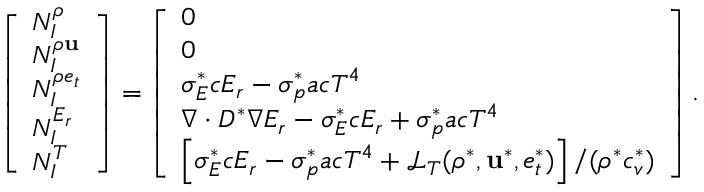Convert formula to latex. <formula><loc_0><loc_0><loc_500><loc_500>\left [ \begin{array} { l } { N _ { I } ^ { \rho } } \\ { N _ { I } ^ { \rho u } } \\ { N _ { I } ^ { \rho e _ { t } } } \\ { N _ { I } ^ { E _ { r } } } \\ { N _ { I } ^ { T } } \end{array} \right ] = \left [ \begin{array} { l } { 0 } \\ { 0 } \\ { \sigma _ { E } ^ { * } c E _ { r } - \sigma _ { p } ^ { * } a c T ^ { 4 } } \\ { \nabla \cdot D ^ { * } \nabla E _ { r } - \sigma _ { E } ^ { * } c E _ { r } + \sigma _ { p } ^ { * } a c T ^ { 4 } } \\ { \left [ \sigma _ { E } ^ { * } c E _ { r } - \sigma _ { p } ^ { * } a c T ^ { 4 } + \mathcal { L } _ { T } ( \rho ^ { * } , u ^ { * } , e _ { t } ^ { * } ) \right ] / ( \rho ^ { * } c _ { v } ^ { * } ) } \end{array} \right ] .</formula> 